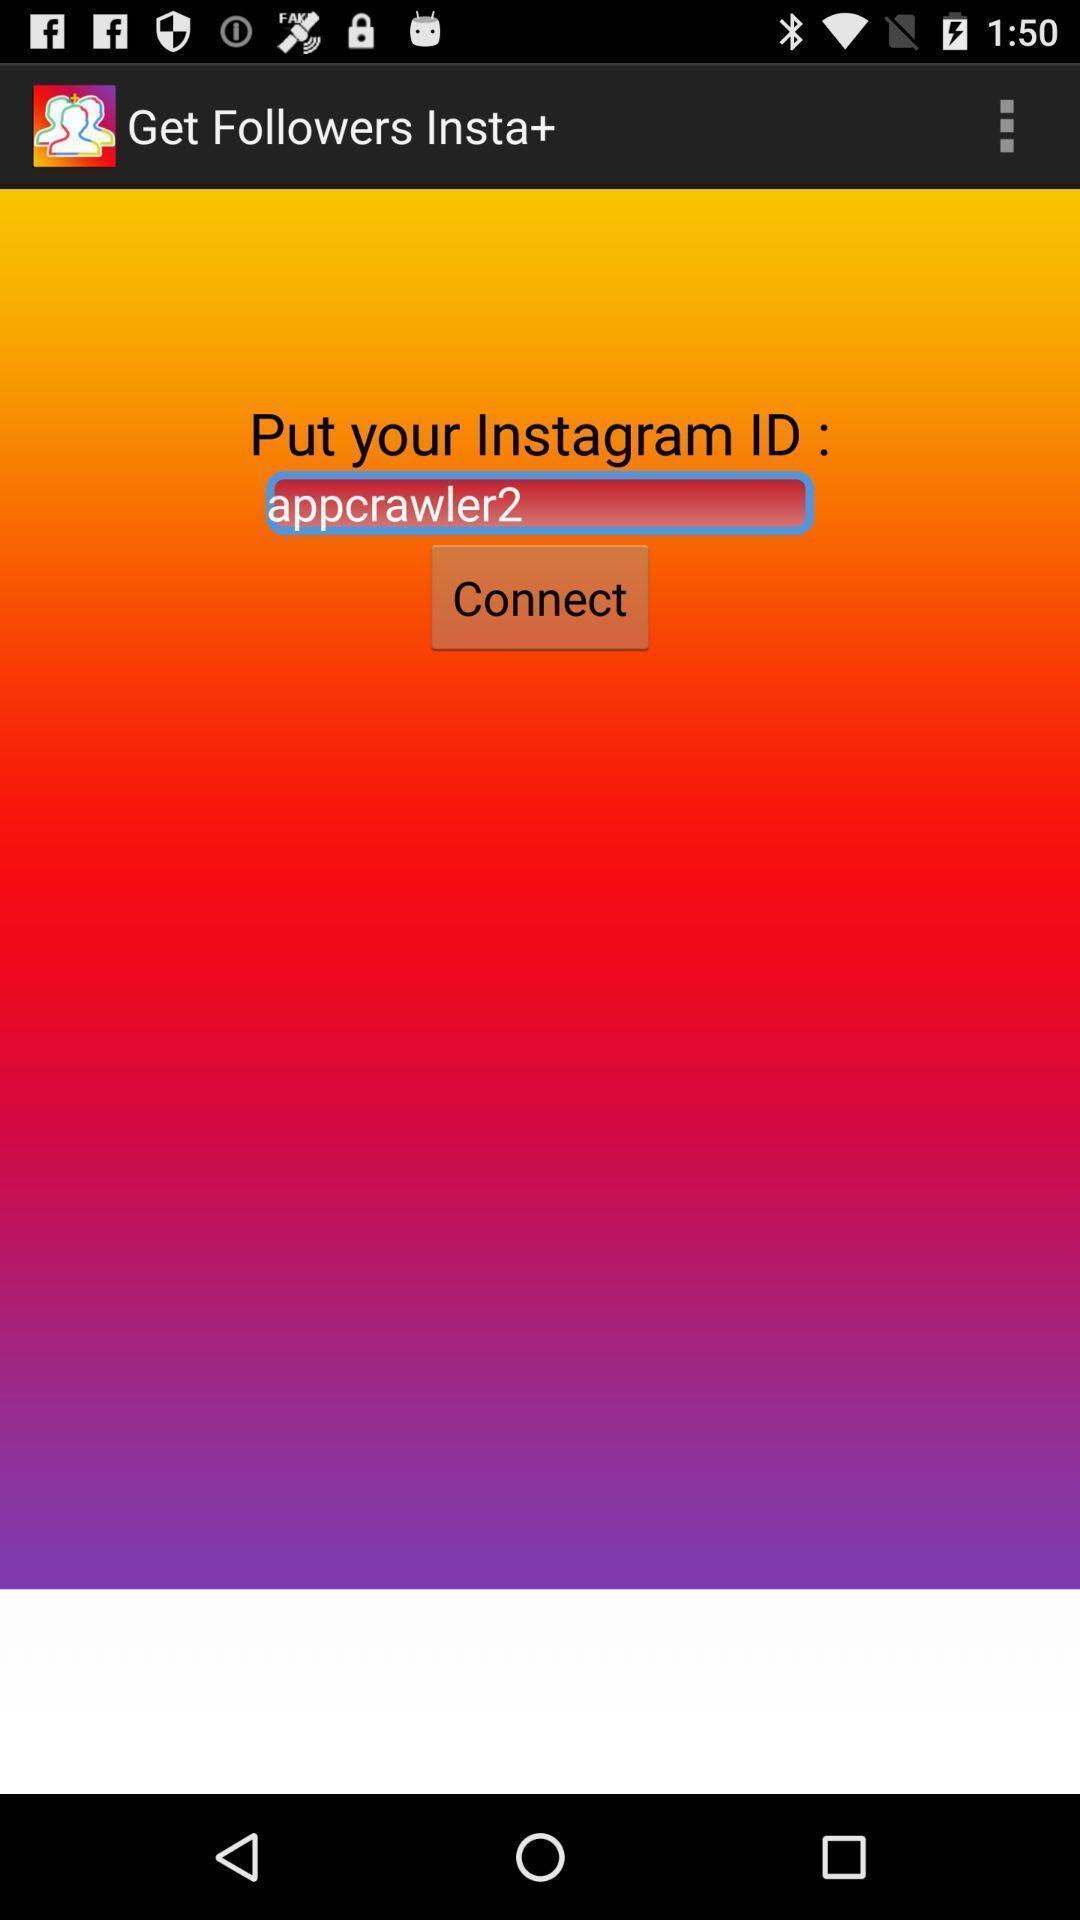Describe the visual elements of this screenshot. Page displaying to enter profile id in an social app. 